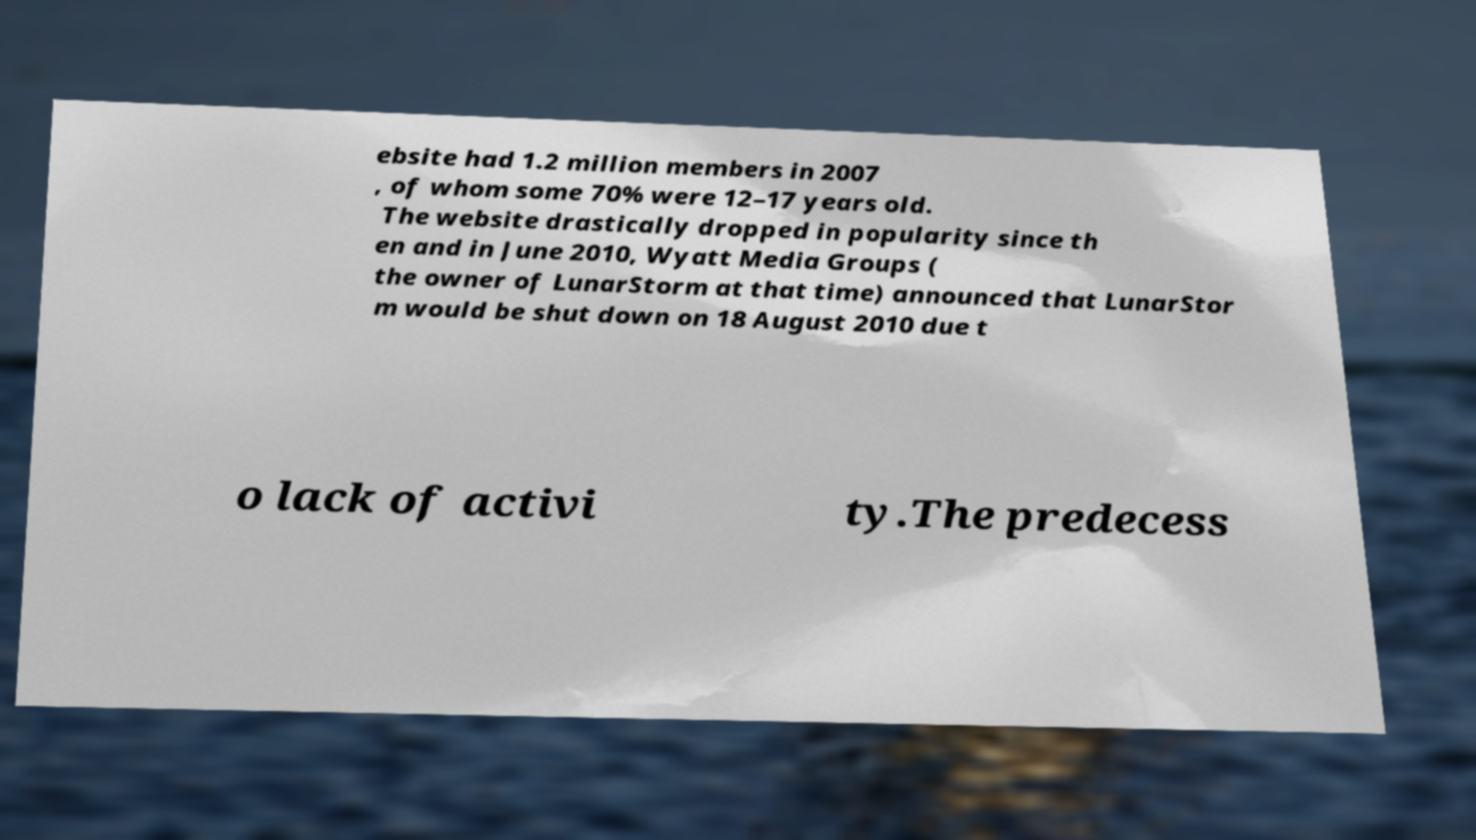What messages or text are displayed in this image? I need them in a readable, typed format. ebsite had 1.2 million members in 2007 , of whom some 70% were 12–17 years old. The website drastically dropped in popularity since th en and in June 2010, Wyatt Media Groups ( the owner of LunarStorm at that time) announced that LunarStor m would be shut down on 18 August 2010 due t o lack of activi ty.The predecess 